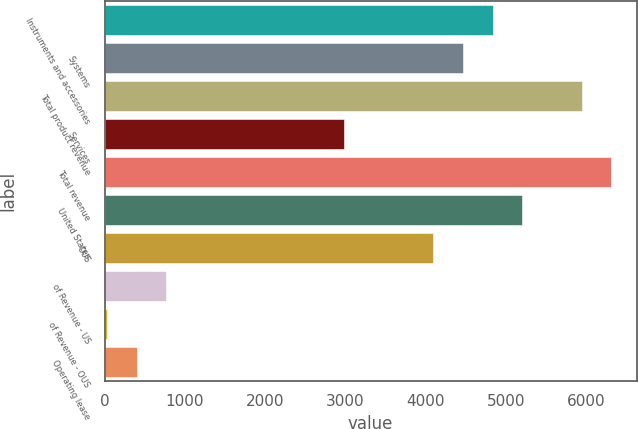Convert chart to OTSL. <chart><loc_0><loc_0><loc_500><loc_500><bar_chart><fcel>Instruments and accessories<fcel>Systems<fcel>Total product revenue<fcel>Services<fcel>Total revenue<fcel>United States<fcel>OUS<fcel>of Revenue - US<fcel>of Revenue - OUS<fcel>Operating lease<nl><fcel>4832.76<fcel>4463.24<fcel>5941.32<fcel>2985.16<fcel>6310.84<fcel>5202.28<fcel>4093.72<fcel>768.04<fcel>29<fcel>398.52<nl></chart> 